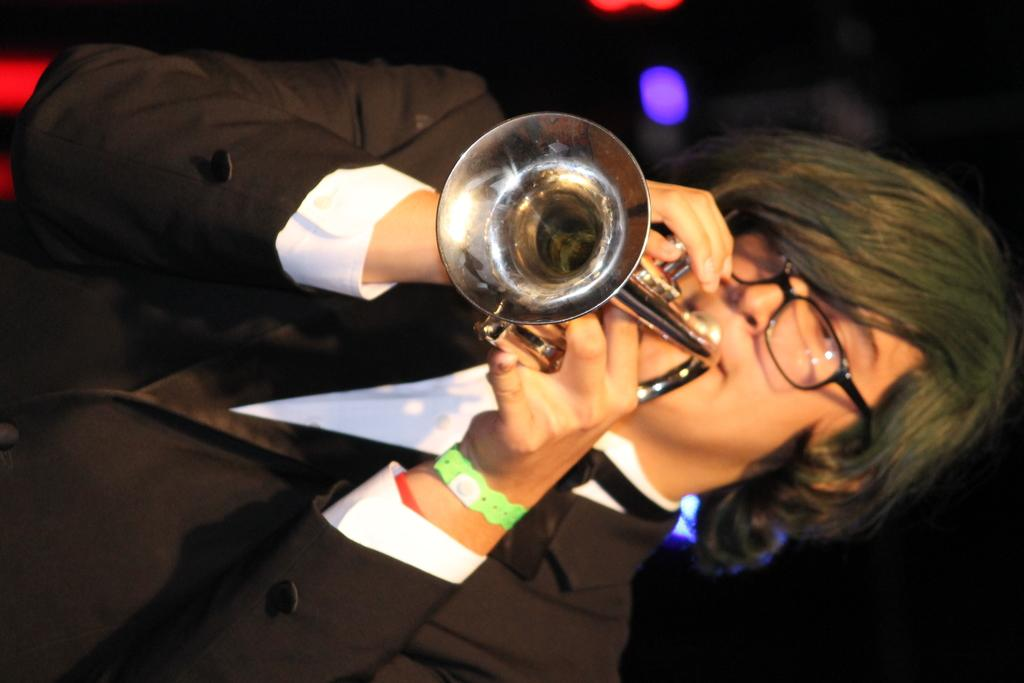Who is the main subject in the image? There is a man in the center of the image. What is the man doing in the image? The man is playing a musical instrument. What is the man wearing in the image? The man is wearing a suit and spectacles. What can be seen in the background of the image? There are lights visible in the background of the image. What word is written on the man's stocking in the image? There is no mention of stockings in the image, and therefore no word can be found on them. 